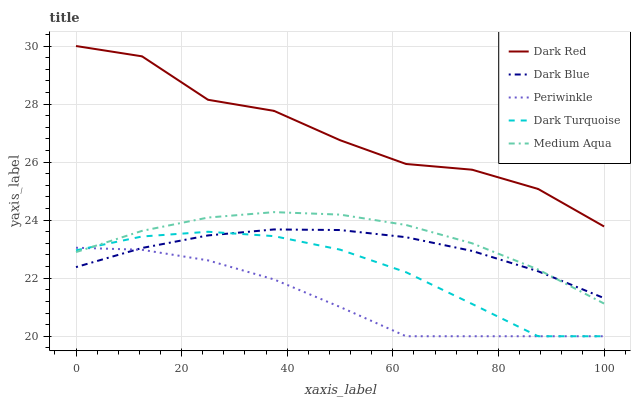Does Periwinkle have the minimum area under the curve?
Answer yes or no. Yes. Does Dark Red have the maximum area under the curve?
Answer yes or no. Yes. Does Dark Red have the minimum area under the curve?
Answer yes or no. No. Does Periwinkle have the maximum area under the curve?
Answer yes or no. No. Is Dark Blue the smoothest?
Answer yes or no. Yes. Is Dark Red the roughest?
Answer yes or no. Yes. Is Periwinkle the smoothest?
Answer yes or no. No. Is Periwinkle the roughest?
Answer yes or no. No. Does Periwinkle have the lowest value?
Answer yes or no. Yes. Does Dark Red have the lowest value?
Answer yes or no. No. Does Dark Red have the highest value?
Answer yes or no. Yes. Does Periwinkle have the highest value?
Answer yes or no. No. Is Dark Turquoise less than Dark Red?
Answer yes or no. Yes. Is Dark Red greater than Medium Aqua?
Answer yes or no. Yes. Does Periwinkle intersect Medium Aqua?
Answer yes or no. Yes. Is Periwinkle less than Medium Aqua?
Answer yes or no. No. Is Periwinkle greater than Medium Aqua?
Answer yes or no. No. Does Dark Turquoise intersect Dark Red?
Answer yes or no. No. 